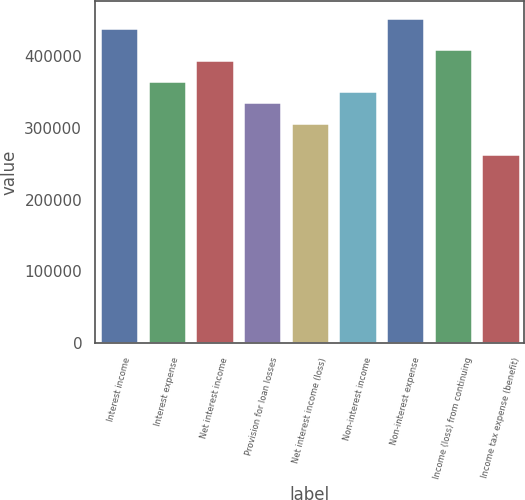Convert chart. <chart><loc_0><loc_0><loc_500><loc_500><bar_chart><fcel>Interest income<fcel>Interest expense<fcel>Net interest income<fcel>Provision for loan losses<fcel>Net interest income (loss)<fcel>Non-interest income<fcel>Non-interest expense<fcel>Income (loss) from continuing<fcel>Income tax expense (benefit)<nl><fcel>438742<fcel>365618<fcel>394868<fcel>336369<fcel>307120<fcel>350994<fcel>453367<fcel>409493<fcel>263246<nl></chart> 